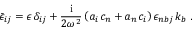<formula> <loc_0><loc_0><loc_500><loc_500>\bar { \epsilon } _ { i j } = \epsilon \, \delta _ { i j } + { \frac { i } { { 2 { \omega } ^ { 2 } } } } \left ( a _ { i } \, c _ { n } + a _ { n } \, c _ { i } \right ) { \epsilon } _ { n b j } \, k _ { b } \, .</formula> 